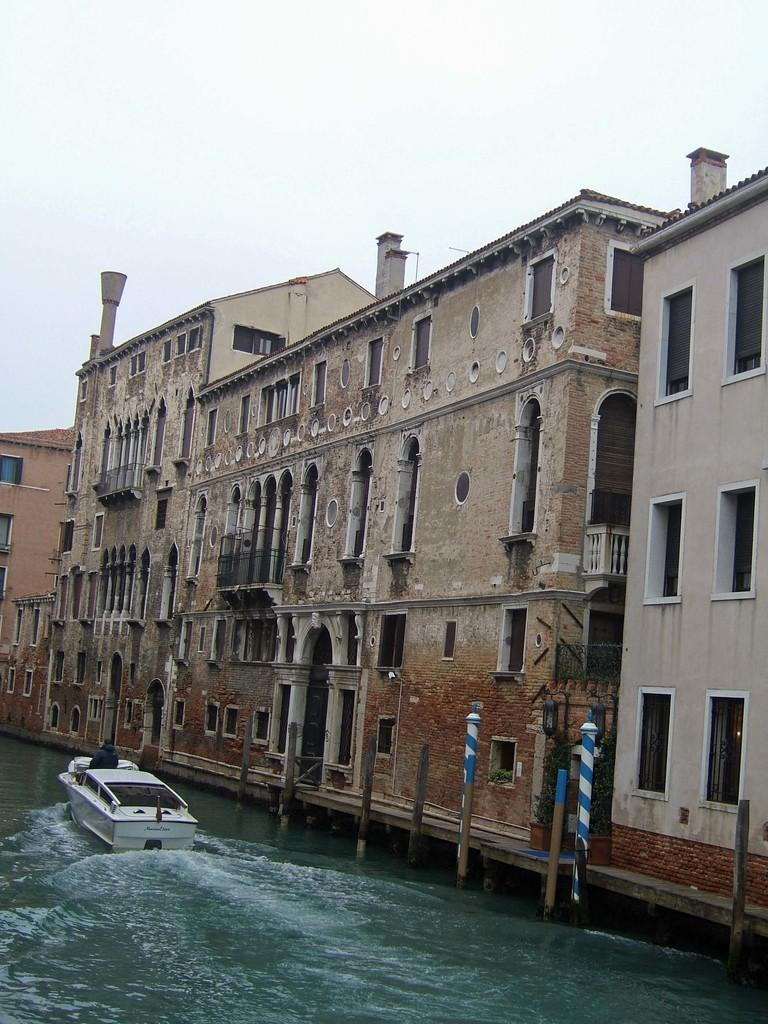What type of buildings can be seen in the image? There are buildings in the image, but the specific type cannot be determined from the facts provided. What is located at the bottom of the image? There is water at the bottom of the image. What is floating on the water? A boat is visible on the water. What can be seen in the background of the image? There is sky in the background of the image. Who is in the boat? There is a person in the boat. What color is the person's hair in the image? There is no information about the person's hair color in the image. How many arches can be seen in the image? There is no mention of arches in the image. 